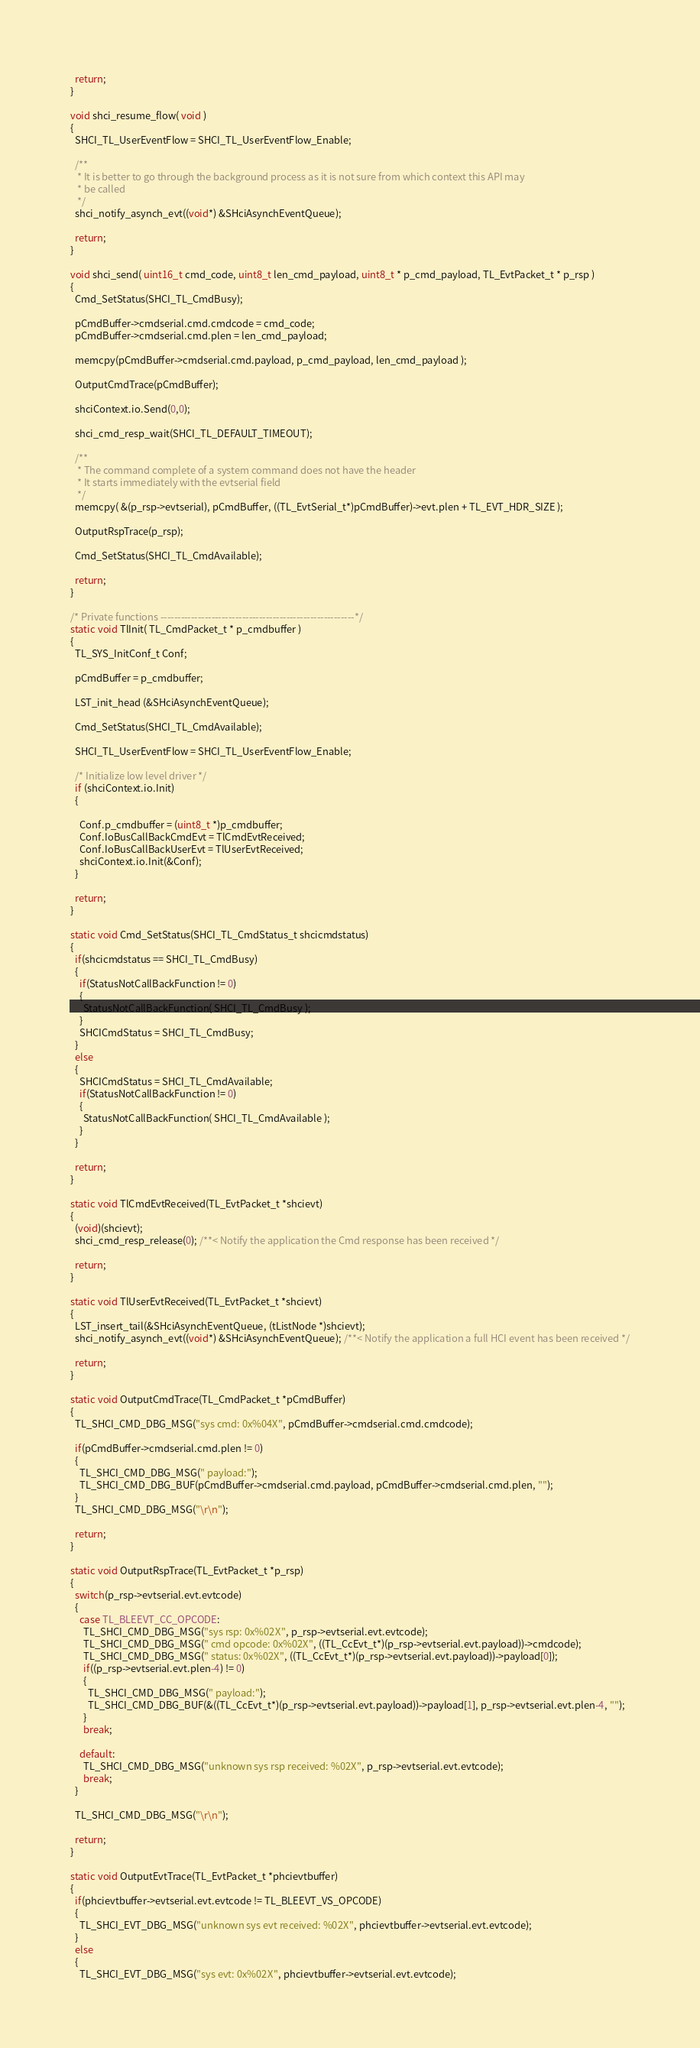Convert code to text. <code><loc_0><loc_0><loc_500><loc_500><_C_>

  return;
}

void shci_resume_flow( void )
{
  SHCI_TL_UserEventFlow = SHCI_TL_UserEventFlow_Enable;

  /**
   * It is better to go through the background process as it is not sure from which context this API may
   * be called
   */
  shci_notify_asynch_evt((void*) &SHciAsynchEventQueue);

  return;
}

void shci_send( uint16_t cmd_code, uint8_t len_cmd_payload, uint8_t * p_cmd_payload, TL_EvtPacket_t * p_rsp )
{
  Cmd_SetStatus(SHCI_TL_CmdBusy);

  pCmdBuffer->cmdserial.cmd.cmdcode = cmd_code;
  pCmdBuffer->cmdserial.cmd.plen = len_cmd_payload;

  memcpy(pCmdBuffer->cmdserial.cmd.payload, p_cmd_payload, len_cmd_payload );

  OutputCmdTrace(pCmdBuffer);

  shciContext.io.Send(0,0);

  shci_cmd_resp_wait(SHCI_TL_DEFAULT_TIMEOUT);

  /**
   * The command complete of a system command does not have the header
   * It starts immediately with the evtserial field
   */
  memcpy( &(p_rsp->evtserial), pCmdBuffer, ((TL_EvtSerial_t*)pCmdBuffer)->evt.plen + TL_EVT_HDR_SIZE );

  OutputRspTrace(p_rsp);

  Cmd_SetStatus(SHCI_TL_CmdAvailable);

  return;
}

/* Private functions ---------------------------------------------------------*/
static void TlInit( TL_CmdPacket_t * p_cmdbuffer )
{
  TL_SYS_InitConf_t Conf;

  pCmdBuffer = p_cmdbuffer;

  LST_init_head (&SHciAsynchEventQueue);

  Cmd_SetStatus(SHCI_TL_CmdAvailable);

  SHCI_TL_UserEventFlow = SHCI_TL_UserEventFlow_Enable;

  /* Initialize low level driver */
  if (shciContext.io.Init)
  {

    Conf.p_cmdbuffer = (uint8_t *)p_cmdbuffer;
    Conf.IoBusCallBackCmdEvt = TlCmdEvtReceived;
    Conf.IoBusCallBackUserEvt = TlUserEvtReceived;
    shciContext.io.Init(&Conf);
  }

  return;
}

static void Cmd_SetStatus(SHCI_TL_CmdStatus_t shcicmdstatus)
{
  if(shcicmdstatus == SHCI_TL_CmdBusy)
  {
    if(StatusNotCallBackFunction != 0)
    {
      StatusNotCallBackFunction( SHCI_TL_CmdBusy );
    }
    SHCICmdStatus = SHCI_TL_CmdBusy;
  }
  else
  {
    SHCICmdStatus = SHCI_TL_CmdAvailable;
    if(StatusNotCallBackFunction != 0)
    {
      StatusNotCallBackFunction( SHCI_TL_CmdAvailable );
    }
  }

  return;
}

static void TlCmdEvtReceived(TL_EvtPacket_t *shcievt)
{
  (void)(shcievt);
  shci_cmd_resp_release(0); /**< Notify the application the Cmd response has been received */

  return;
}

static void TlUserEvtReceived(TL_EvtPacket_t *shcievt)
{
  LST_insert_tail(&SHciAsynchEventQueue, (tListNode *)shcievt);
  shci_notify_asynch_evt((void*) &SHciAsynchEventQueue); /**< Notify the application a full HCI event has been received */

  return;
}

static void OutputCmdTrace(TL_CmdPacket_t *pCmdBuffer)
{
  TL_SHCI_CMD_DBG_MSG("sys cmd: 0x%04X", pCmdBuffer->cmdserial.cmd.cmdcode);

  if(pCmdBuffer->cmdserial.cmd.plen != 0)
  {
    TL_SHCI_CMD_DBG_MSG(" payload:");
    TL_SHCI_CMD_DBG_BUF(pCmdBuffer->cmdserial.cmd.payload, pCmdBuffer->cmdserial.cmd.plen, "");
  }
  TL_SHCI_CMD_DBG_MSG("\r\n");

  return;
}

static void OutputRspTrace(TL_EvtPacket_t *p_rsp)
{
  switch(p_rsp->evtserial.evt.evtcode)
  {
    case TL_BLEEVT_CC_OPCODE:
      TL_SHCI_CMD_DBG_MSG("sys rsp: 0x%02X", p_rsp->evtserial.evt.evtcode);
      TL_SHCI_CMD_DBG_MSG(" cmd opcode: 0x%02X", ((TL_CcEvt_t*)(p_rsp->evtserial.evt.payload))->cmdcode);
      TL_SHCI_CMD_DBG_MSG(" status: 0x%02X", ((TL_CcEvt_t*)(p_rsp->evtserial.evt.payload))->payload[0]);
      if((p_rsp->evtserial.evt.plen-4) != 0)
      {
        TL_SHCI_CMD_DBG_MSG(" payload:");
        TL_SHCI_CMD_DBG_BUF(&((TL_CcEvt_t*)(p_rsp->evtserial.evt.payload))->payload[1], p_rsp->evtserial.evt.plen-4, "");
      }
      break;

    default:
      TL_SHCI_CMD_DBG_MSG("unknown sys rsp received: %02X", p_rsp->evtserial.evt.evtcode);
      break;
  }

  TL_SHCI_CMD_DBG_MSG("\r\n");

  return;
}

static void OutputEvtTrace(TL_EvtPacket_t *phcievtbuffer)
{
  if(phcievtbuffer->evtserial.evt.evtcode != TL_BLEEVT_VS_OPCODE)
  {
    TL_SHCI_EVT_DBG_MSG("unknown sys evt received: %02X", phcievtbuffer->evtserial.evt.evtcode);
  }
  else
  {
    TL_SHCI_EVT_DBG_MSG("sys evt: 0x%02X", phcievtbuffer->evtserial.evt.evtcode);</code> 